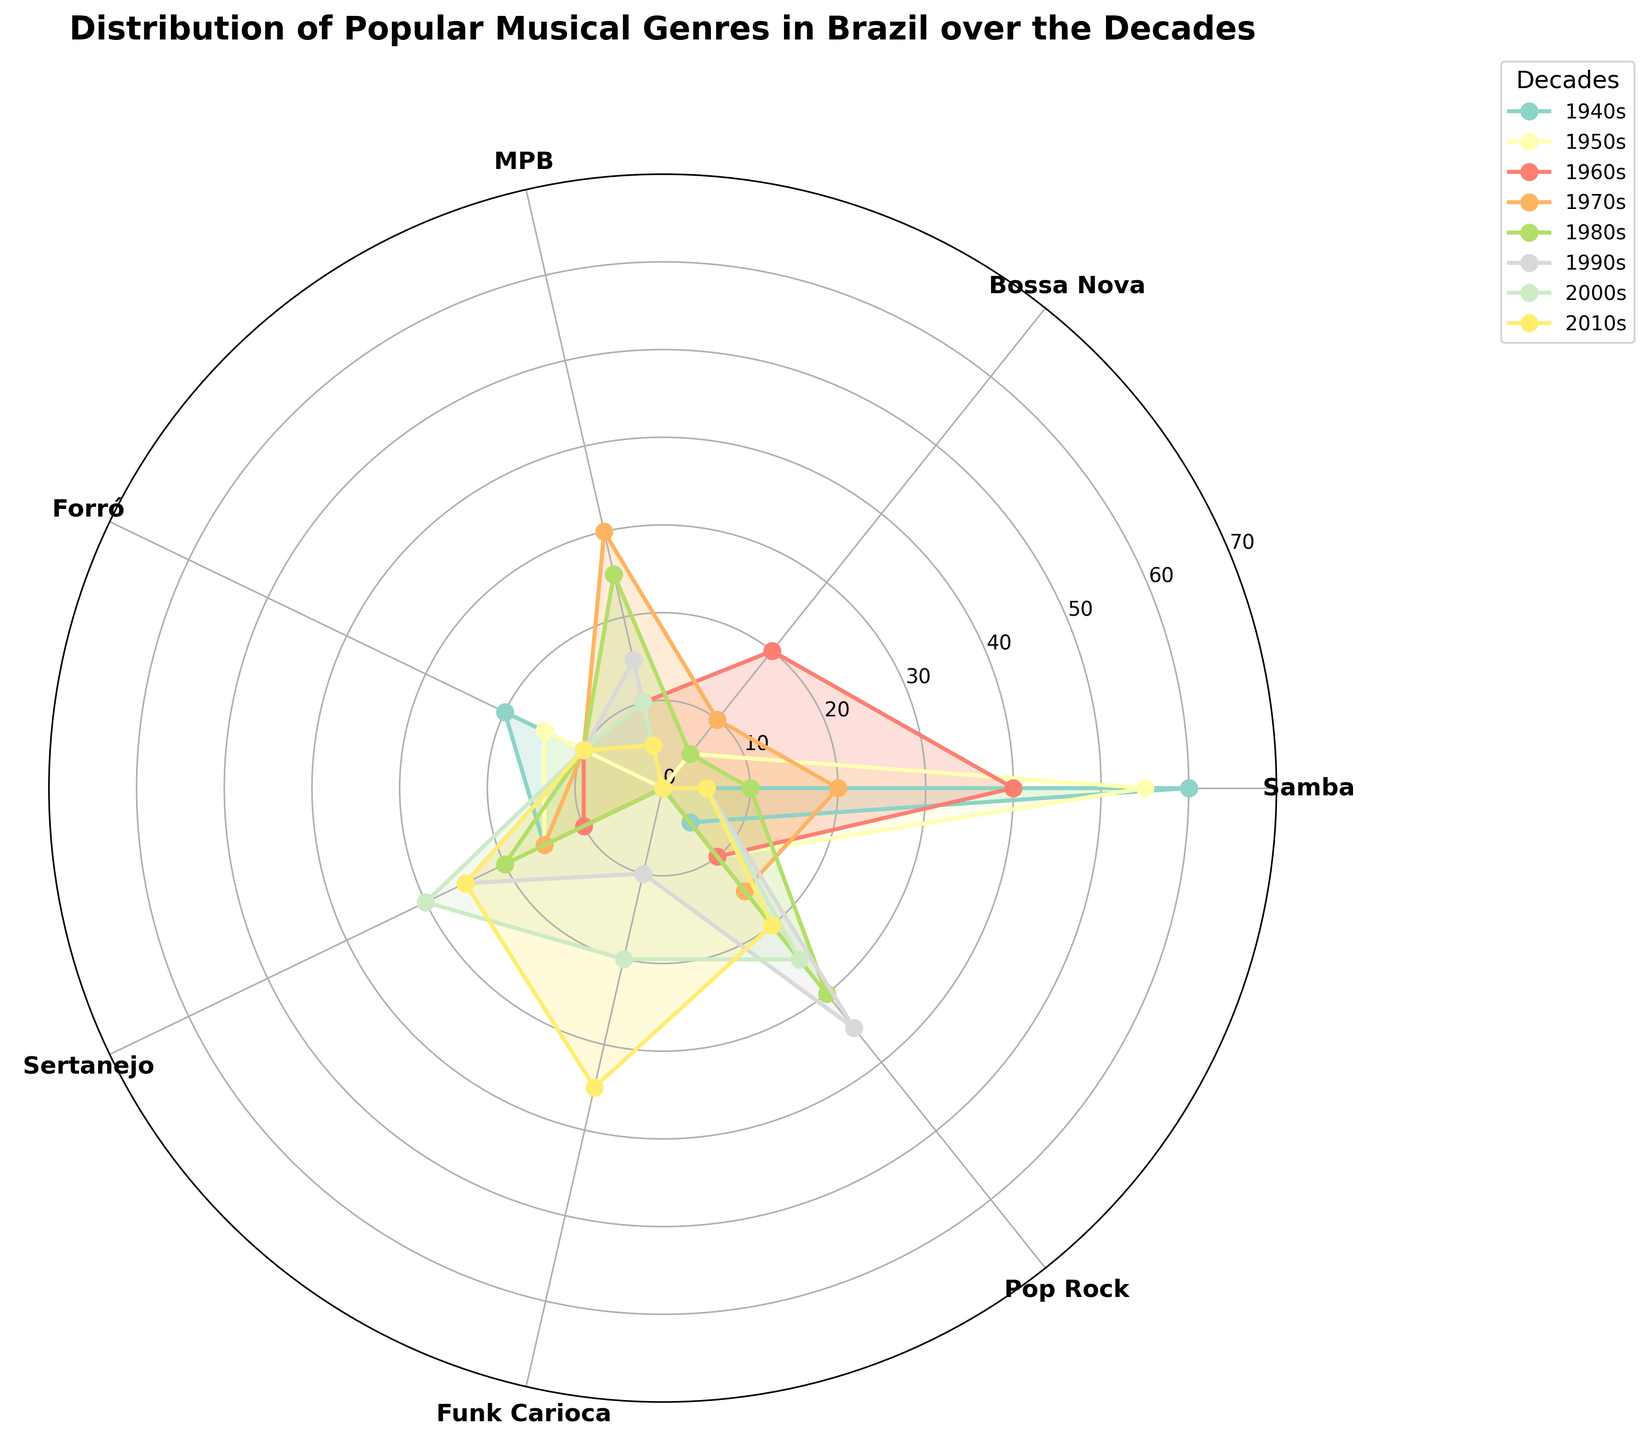What is the title of the figure? The title is typically found at the top of the figure, above the chart itself.
Answer: Distribution of Popular Musical Genres in Brazil over the Decades What genres are consistently represented in each decade? By examining each colored line and which genres they touch across all decades, we can see which genres are consistently represented. Samba, Forró, Sertanejo, and Pop Rock are present in every decade.
Answer: Samba, Forró, Sertanejo, Pop Rock How does the representation of Samba change from the 1940s to the 2010s? Compare the lengths of the lines representing Samba for the 1940s and 2010s. Samba starts with a length of 60 units in the 1940s and reduces to 5 units in the 2010s.
Answer: Decreases from 60 to 5 Which decade shows the highest representation of Funk Carioca? Funk Carioca has a peak in the 2010s. The length of the line representing it in this decade is significantly larger compared to other decades.
Answer: 2010s What genre had the highest increase in popularity from the 1980s to the 2000s? Calculate the difference for each genre between these decades. Funk Carioca increased from 0 in the 1980s to 20 in the 2000s, a difference of 20 units.
Answer: Funk Carioca In which decade did MPB reach its peak representation? Look at the radial distances of the MPB lines in each decade. The longest line is in the 1970s with 30 units.
Answer: 1970s How did the representation of Pop Rock change from the 1990s to the 2010s? Compare the lengths of the lines for Pop Rock in these two decades. Pop Rock decreased from 35 units in the 1990s to 20 units in the 2010s.
Answer: Decreases from 35 to 20 How many genres were popular in the 1940s? Count the number of genres with values greater than 0 in the 1940s. There are five genres: Samba, Forró, Sertanejo, Pop Rock, and one more.
Answer: 5 genres Which decade had the lowest overall representation of Bossa Nova? Check the Bossa Nova values across all decades. The decades showing 0 indicate no representation at all. These are the 1940s, 1990s, 2000s, and 2010s. So, four different decades have the lowest representation (0).
Answer: 1940s, 1990s, 2000s, 2010s What percentage of the total value in the 1970s is represented by Samba? In the 1970s, the total value of all genres is the sum (20 + 10 + 30 + 10 + 15 + 0 + 15 = 100). The Samba value is 20. The percentage is (20 / 100) * 100 = 20%.
Answer: 20% 